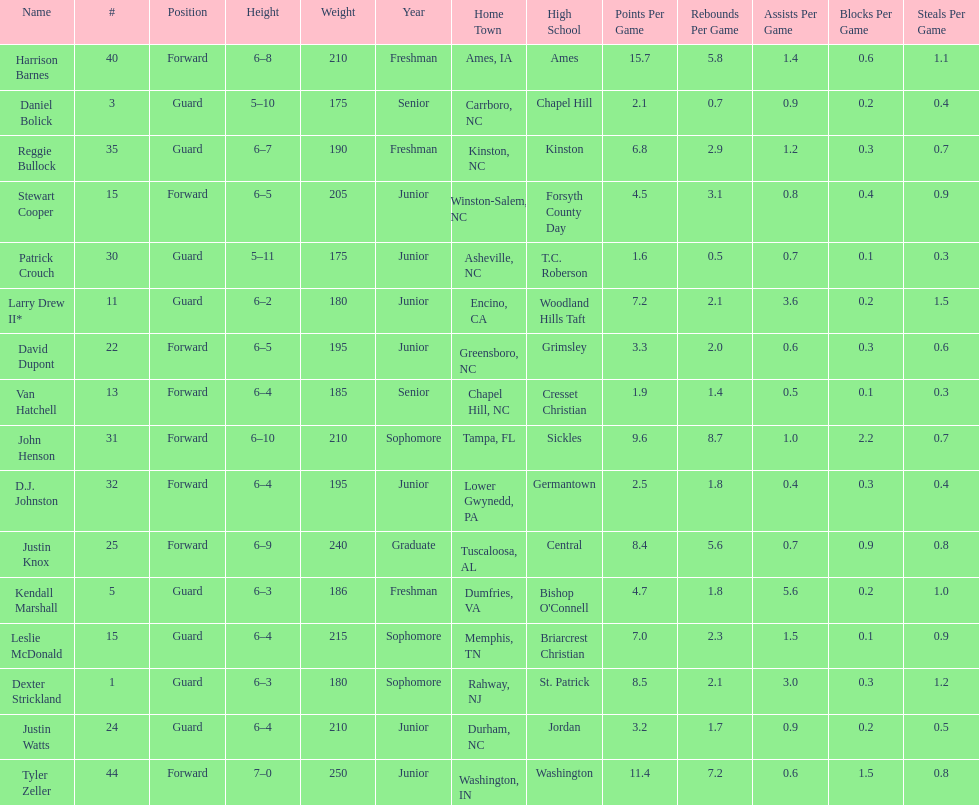How many players were taller than van hatchell? 7. 